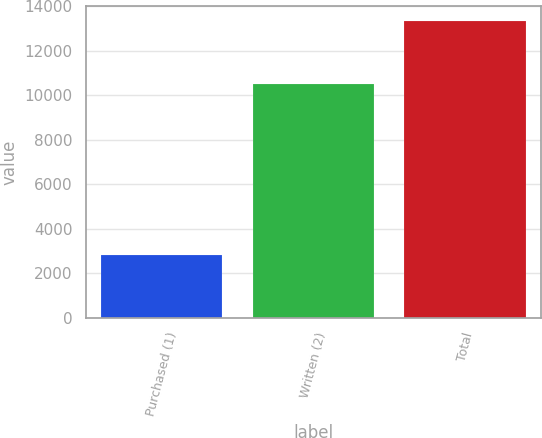Convert chart to OTSL. <chart><loc_0><loc_0><loc_500><loc_500><bar_chart><fcel>Purchased (1)<fcel>Written (2)<fcel>Total<nl><fcel>2830<fcel>10527<fcel>13357<nl></chart> 